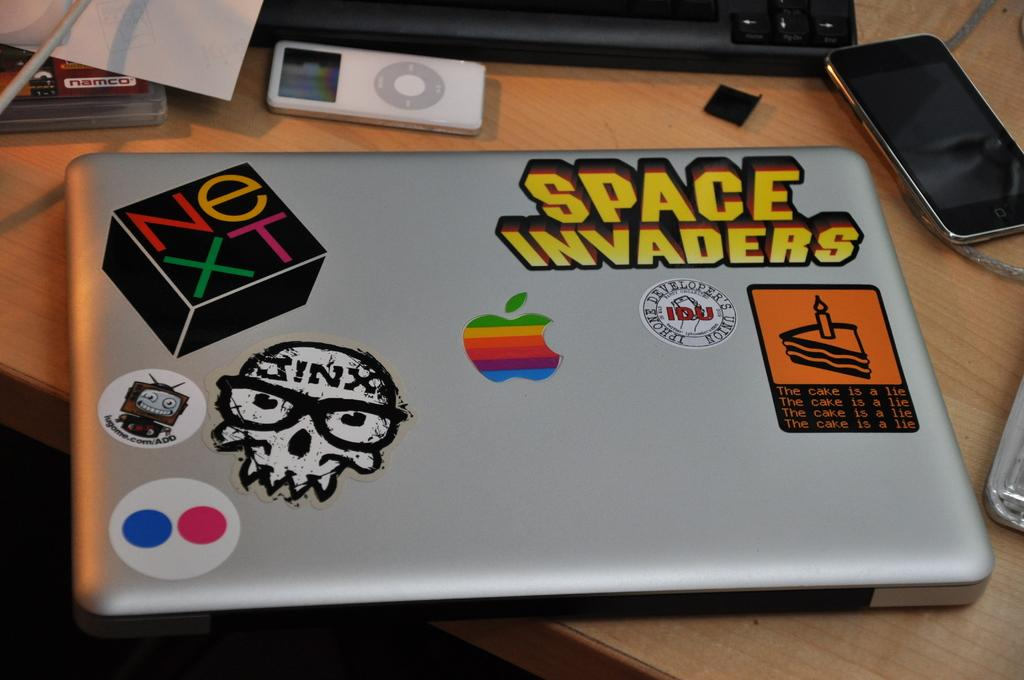What electronic device is the main focus of the image? There is a laptop in the image. What can be observed on the laptop's surface? The laptop has many stickers on it. What other electronic devices are present in the image? There is a phone, a keyboard, and an iPod in the image. Can you describe any other items in the image? There are other unspecified things in the image. What type of chicken is sitting on the keyboard in the image? There is no chicken present in the image; the image features electronic devices and unspecified items. How does the toothpaste help control the iPod's volume in the image? There is no toothpaste or control of the iPod's volume mentioned in the image. 